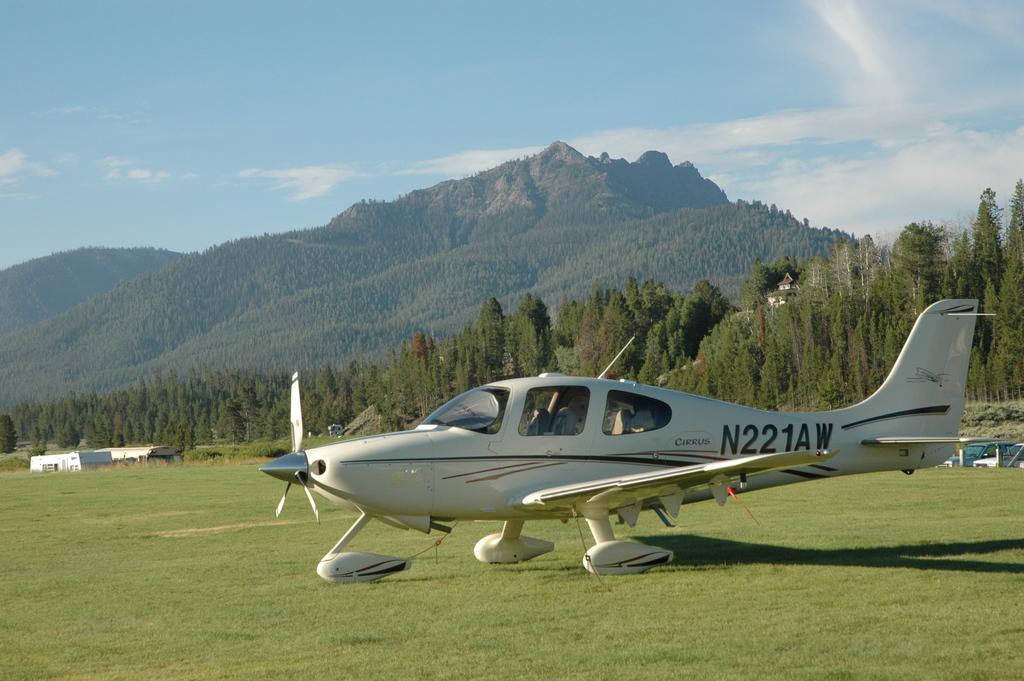Can you describe this image briefly? In the foreground of this picture, there is a airplane on the grass. In the background, there are trees, few buildings, mountains, sky and the cloud. 